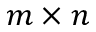<formula> <loc_0><loc_0><loc_500><loc_500>m \times n</formula> 